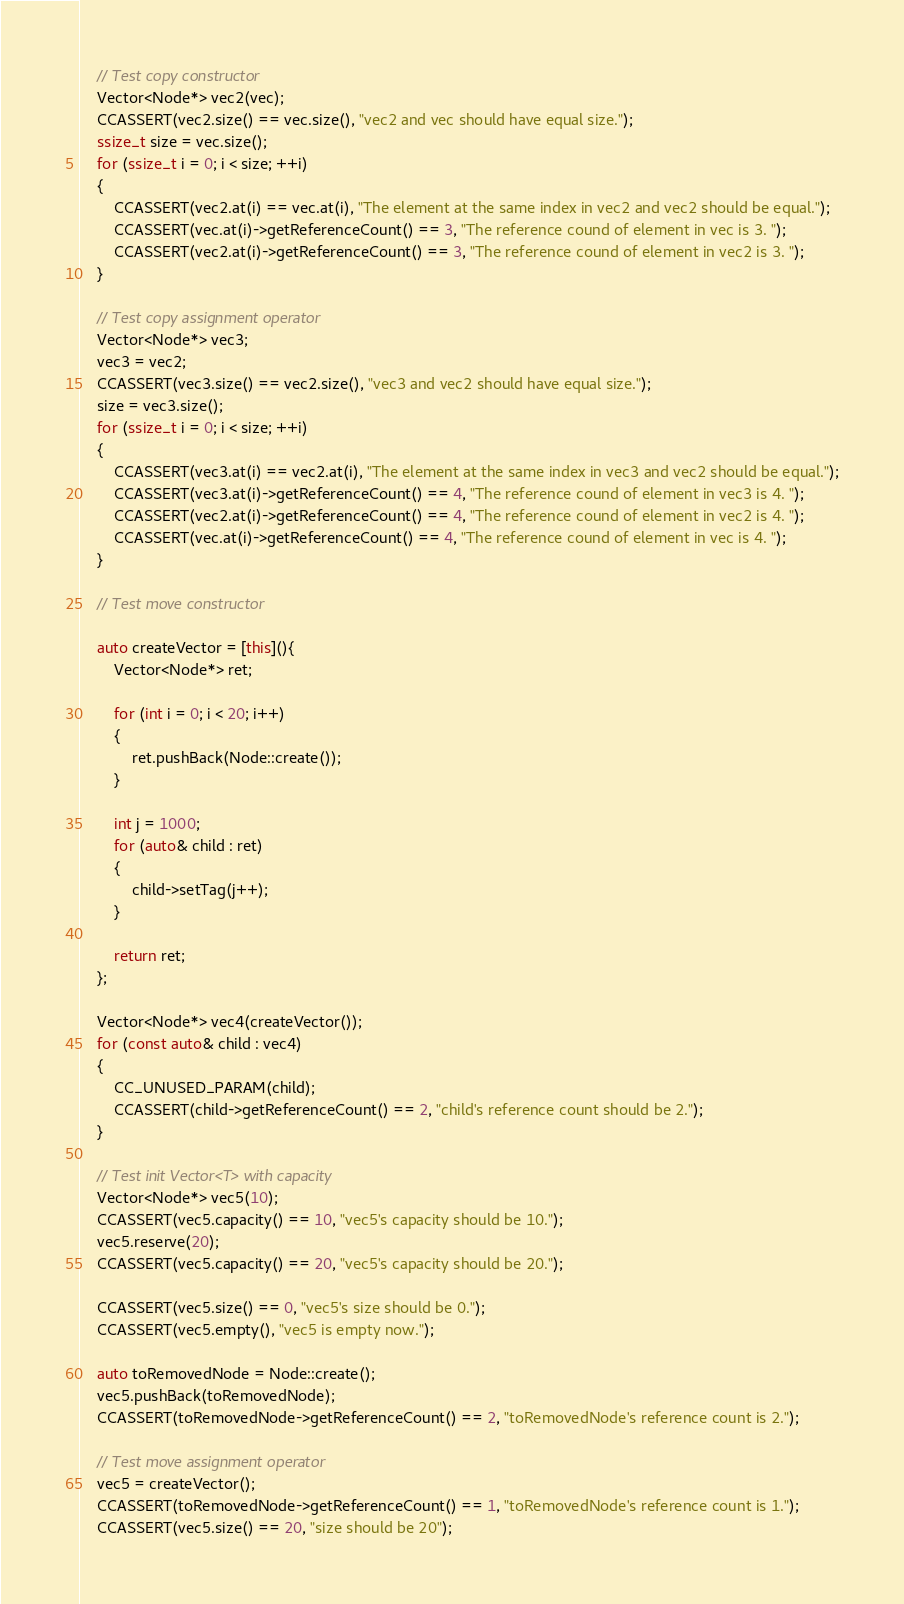<code> <loc_0><loc_0><loc_500><loc_500><_C++_>    // Test copy constructor
    Vector<Node*> vec2(vec);
    CCASSERT(vec2.size() == vec.size(), "vec2 and vec should have equal size.");
    ssize_t size = vec.size();
    for (ssize_t i = 0; i < size; ++i)
    {
        CCASSERT(vec2.at(i) == vec.at(i), "The element at the same index in vec2 and vec2 should be equal.");
        CCASSERT(vec.at(i)->getReferenceCount() == 3, "The reference cound of element in vec is 3. ");
        CCASSERT(vec2.at(i)->getReferenceCount() == 3, "The reference cound of element in vec2 is 3. ");
    }

    // Test copy assignment operator
    Vector<Node*> vec3;
    vec3 = vec2;
    CCASSERT(vec3.size() == vec2.size(), "vec3 and vec2 should have equal size.");
    size = vec3.size();
    for (ssize_t i = 0; i < size; ++i)
    {
        CCASSERT(vec3.at(i) == vec2.at(i), "The element at the same index in vec3 and vec2 should be equal.");
        CCASSERT(vec3.at(i)->getReferenceCount() == 4, "The reference cound of element in vec3 is 4. ");
        CCASSERT(vec2.at(i)->getReferenceCount() == 4, "The reference cound of element in vec2 is 4. ");
        CCASSERT(vec.at(i)->getReferenceCount() == 4, "The reference cound of element in vec is 4. ");
    }

    // Test move constructor

    auto createVector = [this](){
        Vector<Node*> ret;

        for (int i = 0; i < 20; i++)
        {
            ret.pushBack(Node::create());
        }

        int j = 1000;
        for (auto& child : ret)
        {
            child->setTag(j++);
        }

        return ret;
    };

    Vector<Node*> vec4(createVector());
    for (const auto& child : vec4)
    {
        CC_UNUSED_PARAM(child);
        CCASSERT(child->getReferenceCount() == 2, "child's reference count should be 2.");
    }

    // Test init Vector<T> with capacity
    Vector<Node*> vec5(10);
    CCASSERT(vec5.capacity() == 10, "vec5's capacity should be 10.");
    vec5.reserve(20);
    CCASSERT(vec5.capacity() == 20, "vec5's capacity should be 20.");

    CCASSERT(vec5.size() == 0, "vec5's size should be 0.");
    CCASSERT(vec5.empty(), "vec5 is empty now.");

    auto toRemovedNode = Node::create();
    vec5.pushBack(toRemovedNode);
    CCASSERT(toRemovedNode->getReferenceCount() == 2, "toRemovedNode's reference count is 2.");

    // Test move assignment operator
    vec5 = createVector();
    CCASSERT(toRemovedNode->getReferenceCount() == 1, "toRemovedNode's reference count is 1.");
    CCASSERT(vec5.size() == 20, "size should be 20");
</code> 